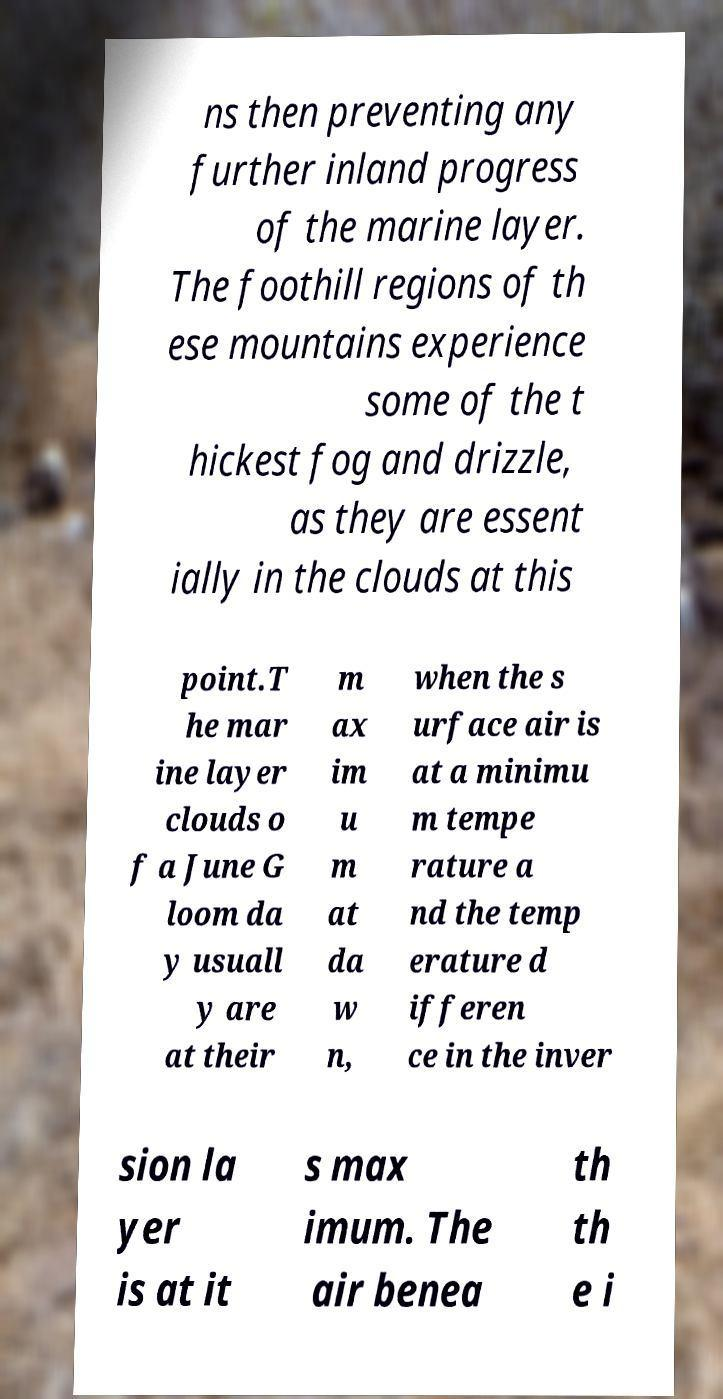Please read and relay the text visible in this image. What does it say? ns then preventing any further inland progress of the marine layer. The foothill regions of th ese mountains experience some of the t hickest fog and drizzle, as they are essent ially in the clouds at this point.T he mar ine layer clouds o f a June G loom da y usuall y are at their m ax im u m at da w n, when the s urface air is at a minimu m tempe rature a nd the temp erature d ifferen ce in the inver sion la yer is at it s max imum. The air benea th th e i 